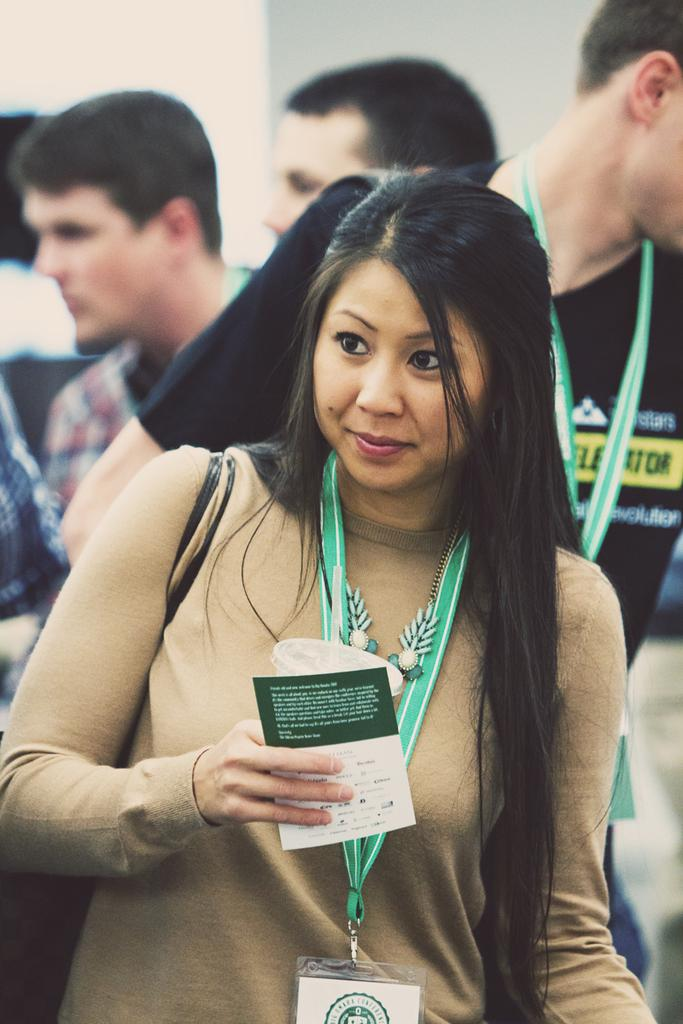What is the main subject of the image? The main subject of the image is a woman. What is the woman doing in the image? The woman is standing in the image. What objects is the woman holding? The woman is holding a cup and a paper in the image. Are there any other people visible in the image? Yes, there are other persons behind the woman in the image. What type of crook can be seen in the image? There is no crook present in the image. Is the woman about to smash the cup in the image? There is no indication in the image that the woman is about to smash the cup. 